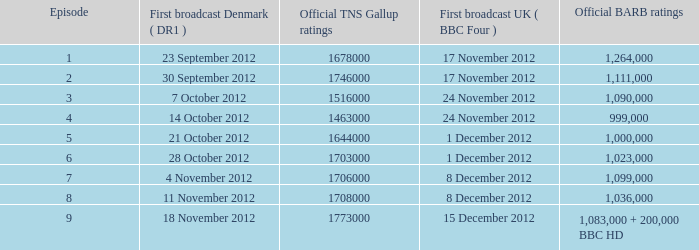When was the episode with a 999,000 barb rating initially broadcasted in denmark? 14 October 2012. 